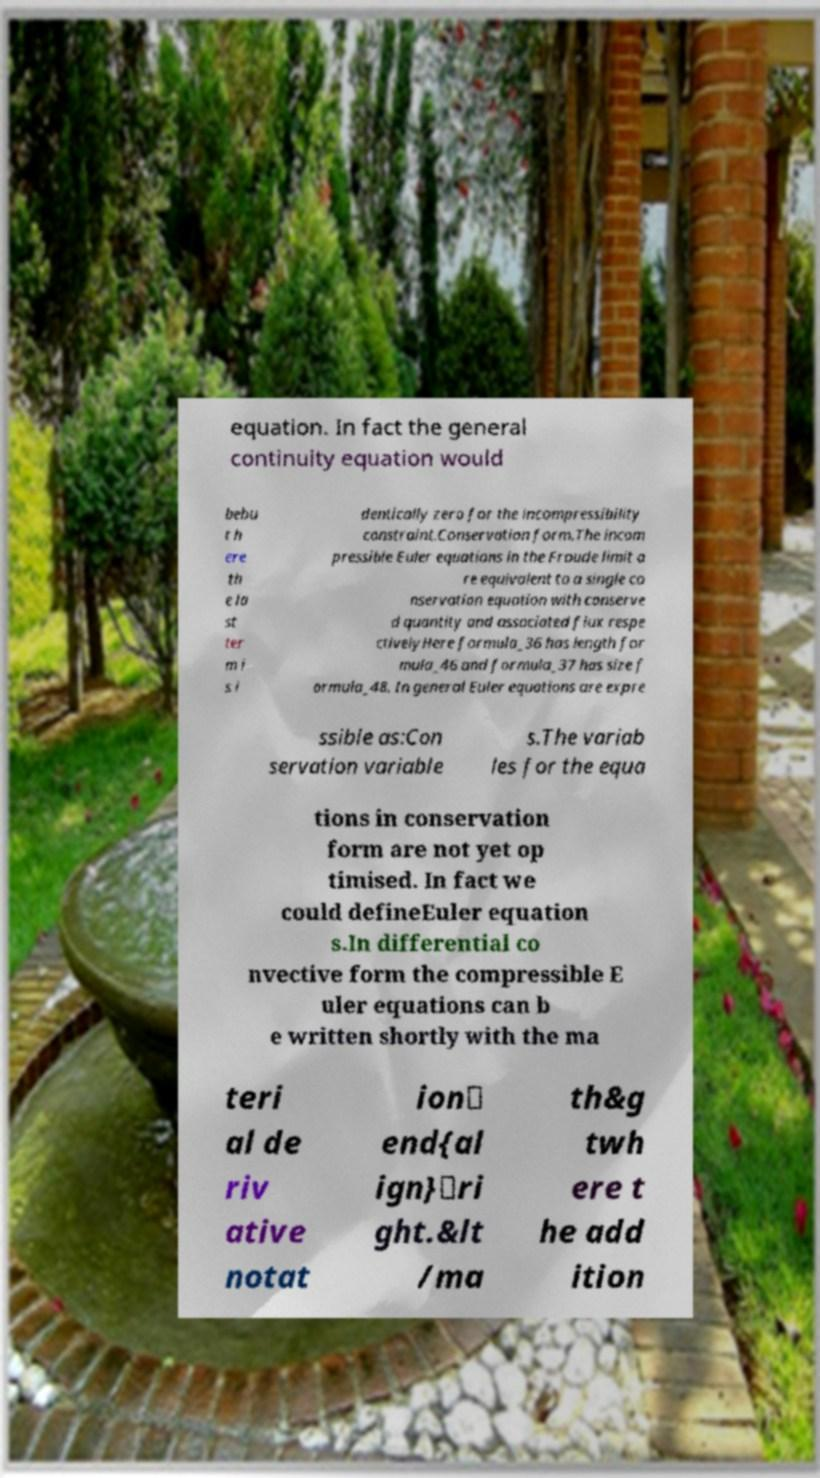There's text embedded in this image that I need extracted. Can you transcribe it verbatim? equation. In fact the general continuity equation would bebu t h ere th e la st ter m i s i dentically zero for the incompressibility constraint.Conservation form.The incom pressible Euler equations in the Froude limit a re equivalent to a single co nservation equation with conserve d quantity and associated flux respe ctivelyHere formula_36 has length for mula_46 and formula_37 has size f ormula_48. In general Euler equations are expre ssible as:Con servation variable s.The variab les for the equa tions in conservation form are not yet op timised. In fact we could defineEuler equation s.In differential co nvective form the compressible E uler equations can b e written shortly with the ma teri al de riv ative notat ion\ end{al ign}\ri ght.&lt /ma th&g twh ere t he add ition 